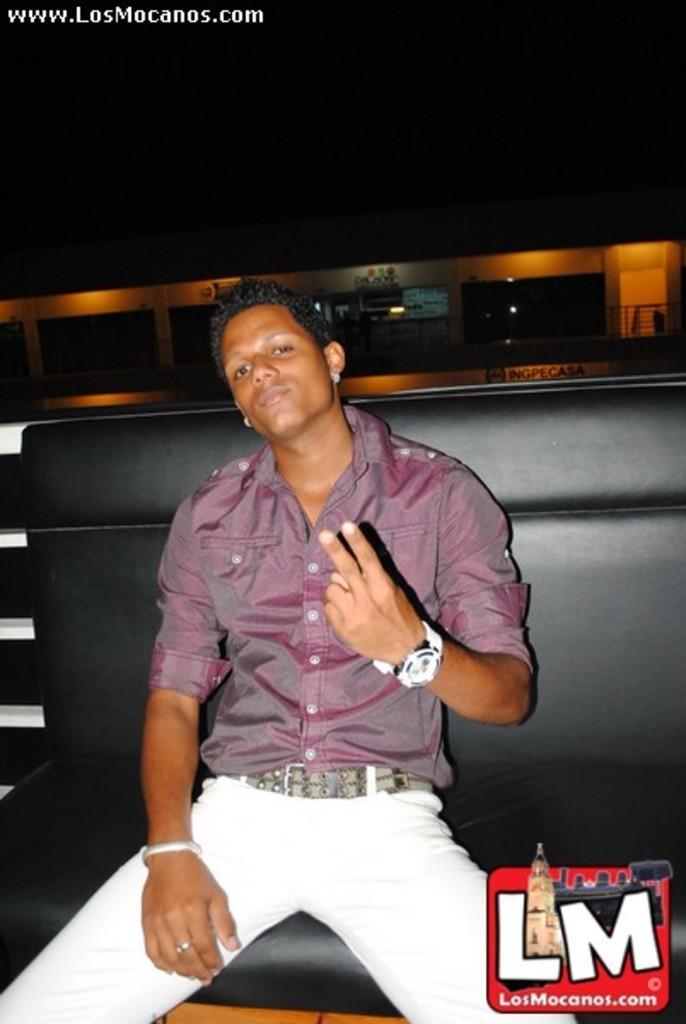Describe this image in one or two sentences. In this image I can see the person is sitting on the black color couch. I can see few lights and the black color background. 